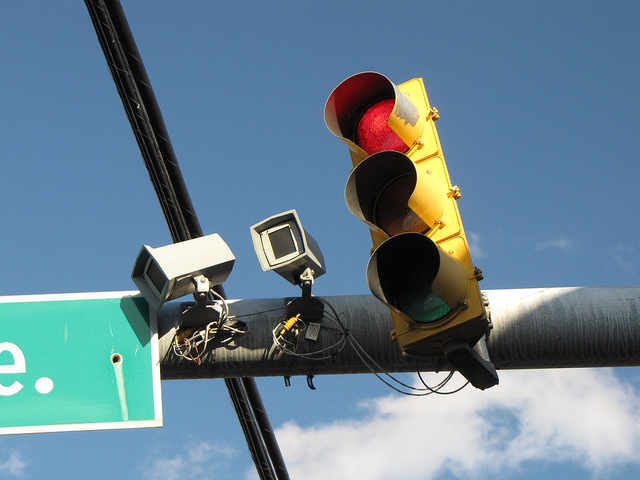What time of day does it appear to be in the image? Given the clear blue sky and the position of the shadows, it appears to be daytime, likely midday or afternoon. 